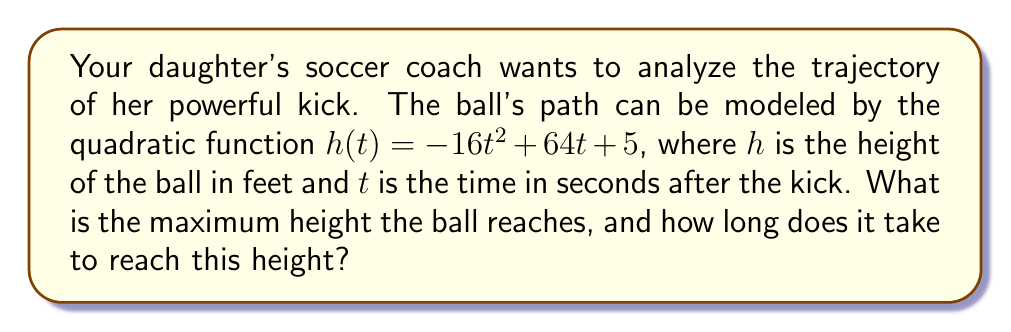Can you solve this math problem? To solve this problem, we'll follow these steps:

1) The quadratic function is in the form $h(t) = -16t^2 + 64t + 5$, which is a parabola opening downward (because the coefficient of $t^2$ is negative).

2) For a quadratic function in the form $f(x) = ax^2 + bx + c$, the vertex formula gives us:
   
   $t = -\frac{b}{2a}$

   where $t$ is the t-coordinate of the vertex (in this case, the time when the ball reaches its maximum height).

3) In our function, $a = -16$ and $b = 64$. Let's substitute these values:

   $t = -\frac{64}{2(-16)} = -\frac{64}{-32} = 2$ seconds

4) To find the maximum height, we substitute this t-value back into our original function:

   $h(2) = -16(2)^2 + 64(2) + 5$
   $= -16(4) + 128 + 5$
   $= -64 + 128 + 5$
   $= 69$ feet

Therefore, the ball reaches its maximum height of 69 feet after 2 seconds.
Answer: The ball reaches a maximum height of 69 feet after 2 seconds. 